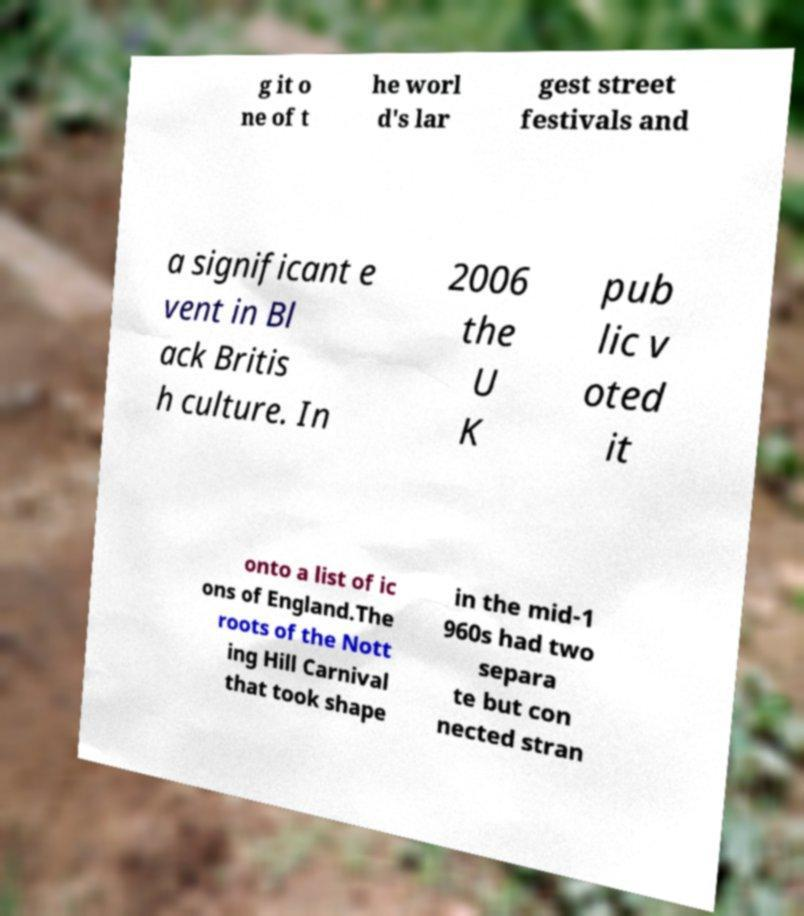Can you accurately transcribe the text from the provided image for me? g it o ne of t he worl d's lar gest street festivals and a significant e vent in Bl ack Britis h culture. In 2006 the U K pub lic v oted it onto a list of ic ons of England.The roots of the Nott ing Hill Carnival that took shape in the mid-1 960s had two separa te but con nected stran 